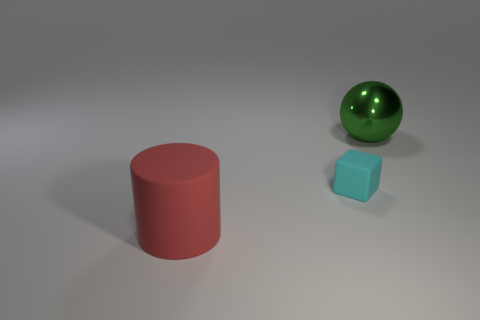Add 1 balls. How many objects exist? 4 Subtract all cylinders. How many objects are left? 2 Subtract all blue balls. Subtract all gray blocks. How many balls are left? 1 Subtract all brown balls. How many purple cylinders are left? 0 Subtract all balls. Subtract all small red matte cubes. How many objects are left? 2 Add 1 cylinders. How many cylinders are left? 2 Add 1 gray shiny things. How many gray shiny things exist? 1 Subtract 0 blue cubes. How many objects are left? 3 